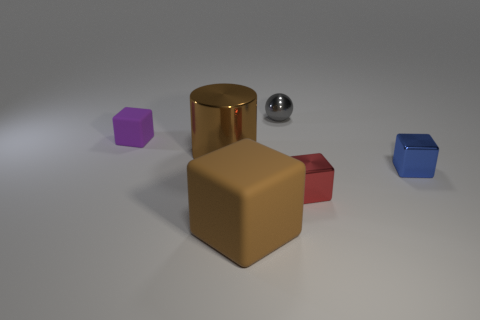What number of big metal objects are the same color as the big rubber block?
Offer a terse response. 1. What number of things are small shiny objects in front of the purple cube or small purple rubber things?
Your response must be concise. 3. There is a cube that is the same material as the purple thing; what is its color?
Keep it short and to the point. Brown. Are there any other objects of the same size as the red metallic thing?
Your answer should be compact. Yes. What number of objects are tiny things behind the purple object or rubber objects in front of the blue metal cube?
Ensure brevity in your answer.  2. What shape is the gray shiny object that is the same size as the blue block?
Offer a very short reply. Sphere. Are there any small gray objects that have the same shape as the small red thing?
Make the answer very short. No. Is the number of red metallic blocks less than the number of cyan shiny spheres?
Your response must be concise. No. There is a block on the left side of the brown cube; does it have the same size as the cube in front of the red block?
Keep it short and to the point. No. What number of things are big brown metallic cylinders or small metallic cubes?
Make the answer very short. 3. 